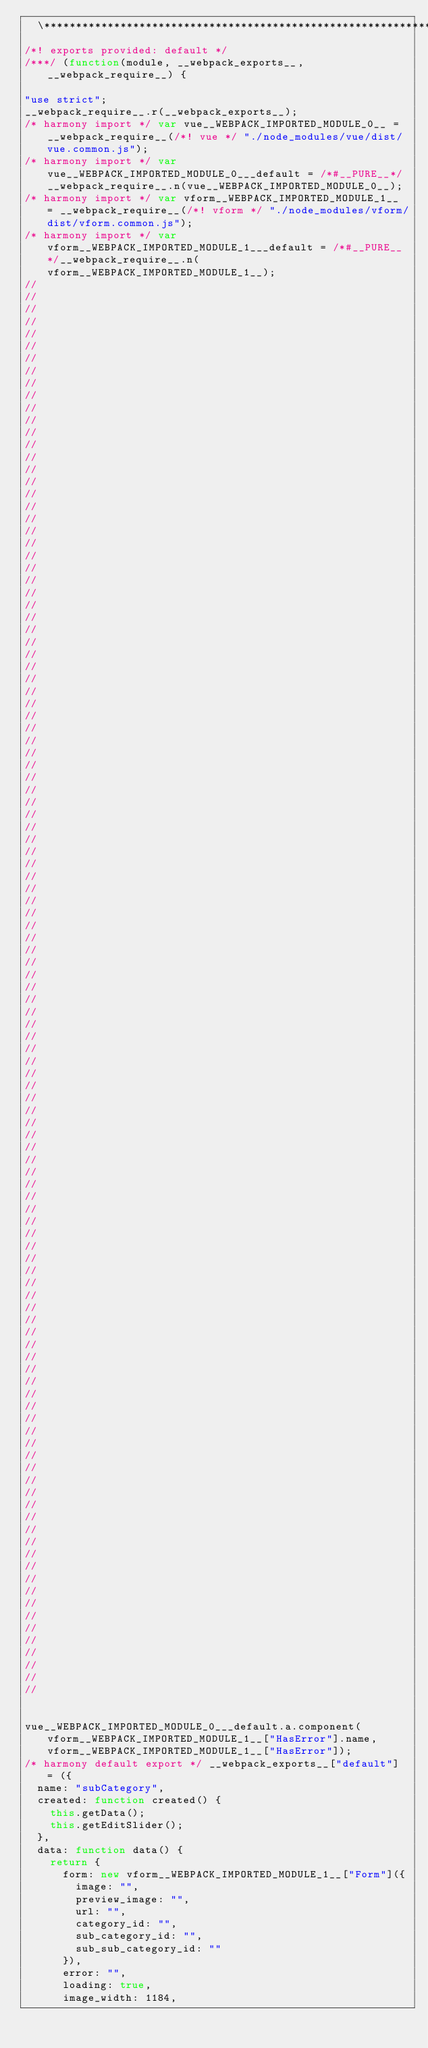<code> <loc_0><loc_0><loc_500><loc_500><_JavaScript_>  \*************************************************************************************************************************************************************************************/
/*! exports provided: default */
/***/ (function(module, __webpack_exports__, __webpack_require__) {

"use strict";
__webpack_require__.r(__webpack_exports__);
/* harmony import */ var vue__WEBPACK_IMPORTED_MODULE_0__ = __webpack_require__(/*! vue */ "./node_modules/vue/dist/vue.common.js");
/* harmony import */ var vue__WEBPACK_IMPORTED_MODULE_0___default = /*#__PURE__*/__webpack_require__.n(vue__WEBPACK_IMPORTED_MODULE_0__);
/* harmony import */ var vform__WEBPACK_IMPORTED_MODULE_1__ = __webpack_require__(/*! vform */ "./node_modules/vform/dist/vform.common.js");
/* harmony import */ var vform__WEBPACK_IMPORTED_MODULE_1___default = /*#__PURE__*/__webpack_require__.n(vform__WEBPACK_IMPORTED_MODULE_1__);
//
//
//
//
//
//
//
//
//
//
//
//
//
//
//
//
//
//
//
//
//
//
//
//
//
//
//
//
//
//
//
//
//
//
//
//
//
//
//
//
//
//
//
//
//
//
//
//
//
//
//
//
//
//
//
//
//
//
//
//
//
//
//
//
//
//
//
//
//
//
//
//
//
//
//
//
//
//
//
//
//
//
//
//
//
//
//
//
//
//
//
//
//
//
//
//
//
//
//
//
//
//
//
//
//
//
//
//
//
//
//
//
//
//
//


vue__WEBPACK_IMPORTED_MODULE_0___default.a.component(vform__WEBPACK_IMPORTED_MODULE_1__["HasError"].name, vform__WEBPACK_IMPORTED_MODULE_1__["HasError"]);
/* harmony default export */ __webpack_exports__["default"] = ({
  name: "subCategory",
  created: function created() {
    this.getData();
    this.getEditSlider();
  },
  data: function data() {
    return {
      form: new vform__WEBPACK_IMPORTED_MODULE_1__["Form"]({
        image: "",
        preview_image: "",
        url: "",
        category_id: "",
        sub_category_id: "",
        sub_sub_category_id: ""
      }),
      error: "",
      loading: true,
      image_width: 1184,</code> 